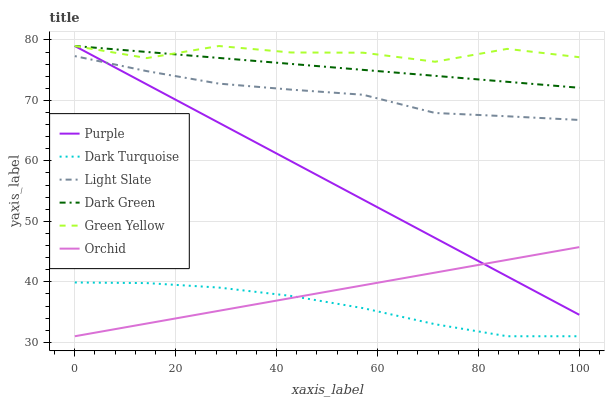Does Dark Turquoise have the minimum area under the curve?
Answer yes or no. Yes. Does Green Yellow have the maximum area under the curve?
Answer yes or no. Yes. Does Dark Green have the minimum area under the curve?
Answer yes or no. No. Does Dark Green have the maximum area under the curve?
Answer yes or no. No. Is Orchid the smoothest?
Answer yes or no. Yes. Is Green Yellow the roughest?
Answer yes or no. Yes. Is Dark Turquoise the smoothest?
Answer yes or no. No. Is Dark Turquoise the roughest?
Answer yes or no. No. Does Dark Turquoise have the lowest value?
Answer yes or no. Yes. Does Dark Green have the lowest value?
Answer yes or no. No. Does Green Yellow have the highest value?
Answer yes or no. Yes. Does Dark Turquoise have the highest value?
Answer yes or no. No. Is Orchid less than Green Yellow?
Answer yes or no. Yes. Is Green Yellow greater than Orchid?
Answer yes or no. Yes. Does Green Yellow intersect Dark Green?
Answer yes or no. Yes. Is Green Yellow less than Dark Green?
Answer yes or no. No. Is Green Yellow greater than Dark Green?
Answer yes or no. No. Does Orchid intersect Green Yellow?
Answer yes or no. No. 